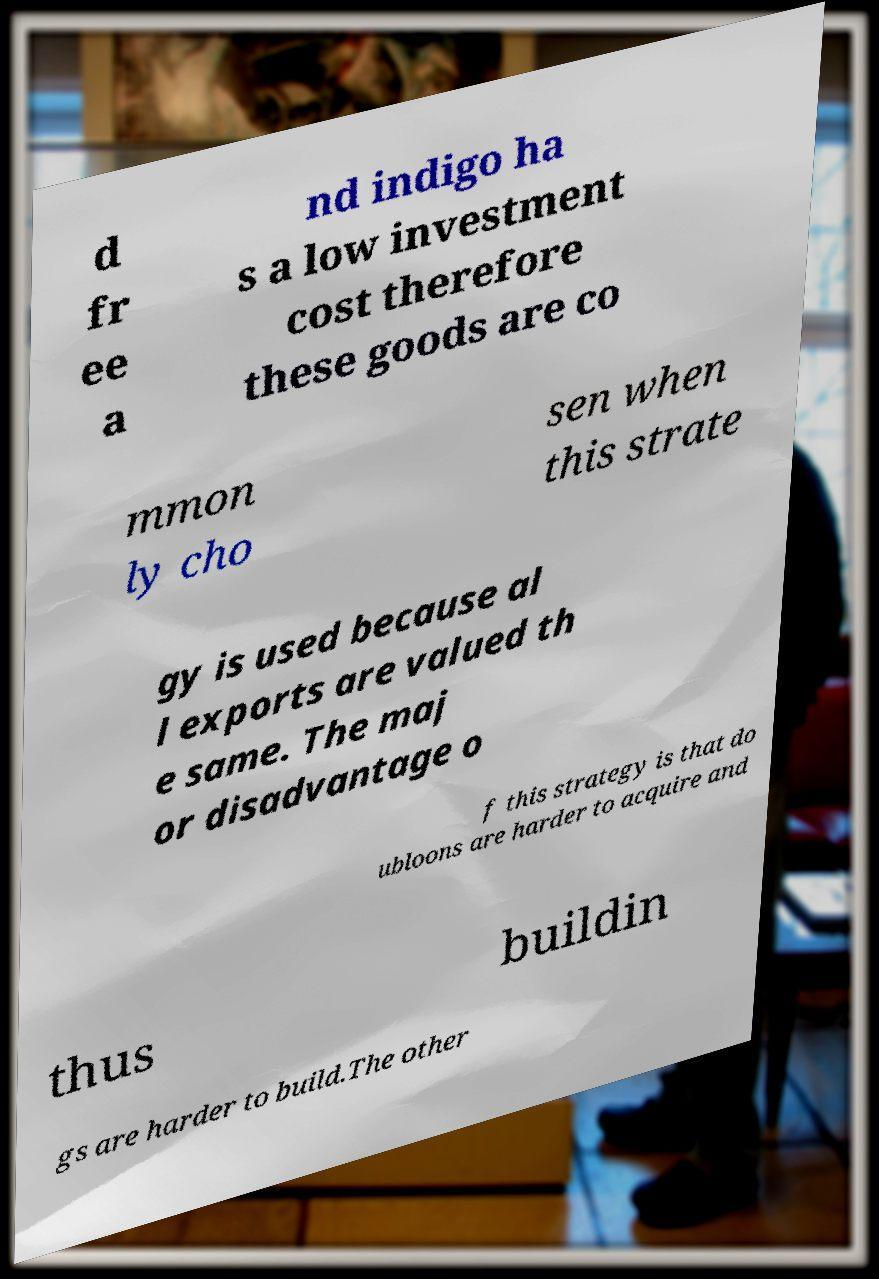Can you accurately transcribe the text from the provided image for me? d fr ee a nd indigo ha s a low investment cost therefore these goods are co mmon ly cho sen when this strate gy is used because al l exports are valued th e same. The maj or disadvantage o f this strategy is that do ubloons are harder to acquire and thus buildin gs are harder to build.The other 